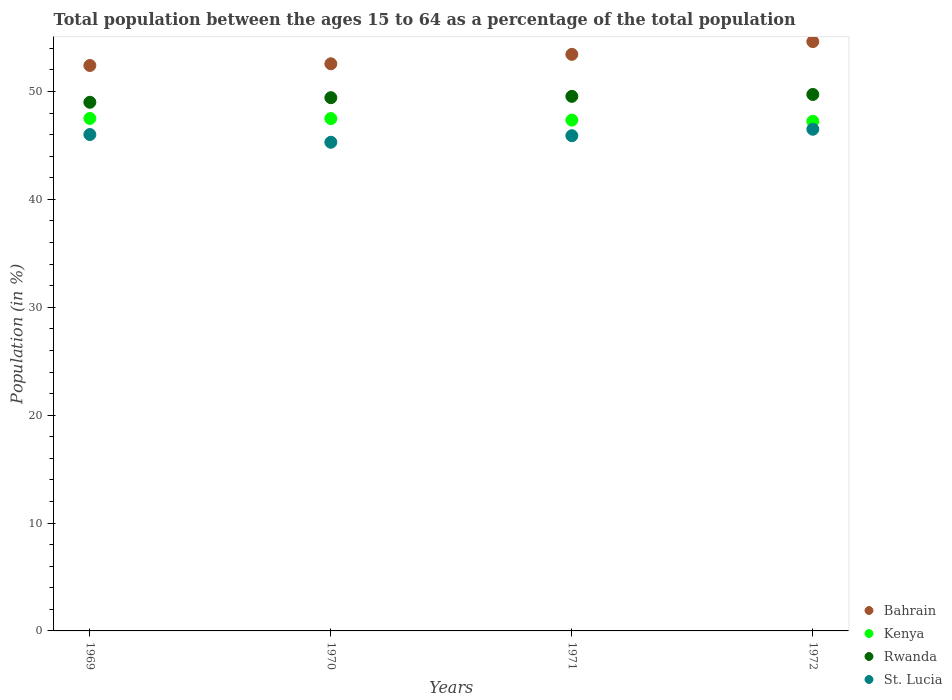What is the percentage of the population ages 15 to 64 in Bahrain in 1969?
Ensure brevity in your answer.  52.42. Across all years, what is the maximum percentage of the population ages 15 to 64 in St. Lucia?
Offer a terse response. 46.5. Across all years, what is the minimum percentage of the population ages 15 to 64 in Kenya?
Offer a very short reply. 47.24. In which year was the percentage of the population ages 15 to 64 in Kenya maximum?
Keep it short and to the point. 1969. In which year was the percentage of the population ages 15 to 64 in St. Lucia minimum?
Make the answer very short. 1970. What is the total percentage of the population ages 15 to 64 in Rwanda in the graph?
Your response must be concise. 197.72. What is the difference between the percentage of the population ages 15 to 64 in St. Lucia in 1969 and that in 1970?
Provide a succinct answer. 0.72. What is the difference between the percentage of the population ages 15 to 64 in St. Lucia in 1971 and the percentage of the population ages 15 to 64 in Bahrain in 1970?
Give a very brief answer. -6.67. What is the average percentage of the population ages 15 to 64 in Kenya per year?
Offer a very short reply. 47.4. In the year 1969, what is the difference between the percentage of the population ages 15 to 64 in Rwanda and percentage of the population ages 15 to 64 in Kenya?
Give a very brief answer. 1.5. What is the ratio of the percentage of the population ages 15 to 64 in St. Lucia in 1969 to that in 1972?
Offer a very short reply. 0.99. Is the difference between the percentage of the population ages 15 to 64 in Rwanda in 1970 and 1972 greater than the difference between the percentage of the population ages 15 to 64 in Kenya in 1970 and 1972?
Make the answer very short. No. What is the difference between the highest and the second highest percentage of the population ages 15 to 64 in Bahrain?
Keep it short and to the point. 1.18. What is the difference between the highest and the lowest percentage of the population ages 15 to 64 in Kenya?
Your answer should be compact. 0.27. Is the sum of the percentage of the population ages 15 to 64 in Rwanda in 1971 and 1972 greater than the maximum percentage of the population ages 15 to 64 in Kenya across all years?
Your answer should be compact. Yes. Is it the case that in every year, the sum of the percentage of the population ages 15 to 64 in Kenya and percentage of the population ages 15 to 64 in Rwanda  is greater than the sum of percentage of the population ages 15 to 64 in St. Lucia and percentage of the population ages 15 to 64 in Bahrain?
Provide a short and direct response. Yes. Is it the case that in every year, the sum of the percentage of the population ages 15 to 64 in Bahrain and percentage of the population ages 15 to 64 in Rwanda  is greater than the percentage of the population ages 15 to 64 in St. Lucia?
Provide a short and direct response. Yes. How many years are there in the graph?
Give a very brief answer. 4. What is the difference between two consecutive major ticks on the Y-axis?
Make the answer very short. 10. Does the graph contain any zero values?
Give a very brief answer. No. How many legend labels are there?
Ensure brevity in your answer.  4. What is the title of the graph?
Offer a terse response. Total population between the ages 15 to 64 as a percentage of the total population. Does "Saudi Arabia" appear as one of the legend labels in the graph?
Offer a very short reply. No. What is the label or title of the X-axis?
Offer a terse response. Years. What is the label or title of the Y-axis?
Your answer should be compact. Population (in %). What is the Population (in %) of Bahrain in 1969?
Provide a succinct answer. 52.42. What is the Population (in %) in Kenya in 1969?
Give a very brief answer. 47.51. What is the Population (in %) in Rwanda in 1969?
Offer a terse response. 49. What is the Population (in %) in St. Lucia in 1969?
Keep it short and to the point. 46.01. What is the Population (in %) of Bahrain in 1970?
Your answer should be very brief. 52.57. What is the Population (in %) in Kenya in 1970?
Offer a very short reply. 47.49. What is the Population (in %) of Rwanda in 1970?
Provide a succinct answer. 49.43. What is the Population (in %) in St. Lucia in 1970?
Your answer should be compact. 45.3. What is the Population (in %) of Bahrain in 1971?
Give a very brief answer. 53.45. What is the Population (in %) in Kenya in 1971?
Provide a short and direct response. 47.35. What is the Population (in %) of Rwanda in 1971?
Provide a short and direct response. 49.55. What is the Population (in %) in St. Lucia in 1971?
Your response must be concise. 45.91. What is the Population (in %) of Bahrain in 1972?
Make the answer very short. 54.63. What is the Population (in %) in Kenya in 1972?
Provide a short and direct response. 47.24. What is the Population (in %) of Rwanda in 1972?
Ensure brevity in your answer.  49.73. What is the Population (in %) of St. Lucia in 1972?
Your answer should be very brief. 46.5. Across all years, what is the maximum Population (in %) of Bahrain?
Your answer should be compact. 54.63. Across all years, what is the maximum Population (in %) of Kenya?
Offer a terse response. 47.51. Across all years, what is the maximum Population (in %) in Rwanda?
Your response must be concise. 49.73. Across all years, what is the maximum Population (in %) of St. Lucia?
Make the answer very short. 46.5. Across all years, what is the minimum Population (in %) in Bahrain?
Your answer should be very brief. 52.42. Across all years, what is the minimum Population (in %) of Kenya?
Offer a very short reply. 47.24. Across all years, what is the minimum Population (in %) of Rwanda?
Offer a very short reply. 49. Across all years, what is the minimum Population (in %) of St. Lucia?
Provide a short and direct response. 45.3. What is the total Population (in %) of Bahrain in the graph?
Make the answer very short. 213.07. What is the total Population (in %) in Kenya in the graph?
Give a very brief answer. 189.59. What is the total Population (in %) of Rwanda in the graph?
Your response must be concise. 197.72. What is the total Population (in %) of St. Lucia in the graph?
Provide a succinct answer. 183.72. What is the difference between the Population (in %) of Bahrain in 1969 and that in 1970?
Provide a succinct answer. -0.16. What is the difference between the Population (in %) in Kenya in 1969 and that in 1970?
Ensure brevity in your answer.  0.01. What is the difference between the Population (in %) of Rwanda in 1969 and that in 1970?
Keep it short and to the point. -0.43. What is the difference between the Population (in %) in St. Lucia in 1969 and that in 1970?
Give a very brief answer. 0.72. What is the difference between the Population (in %) of Bahrain in 1969 and that in 1971?
Provide a short and direct response. -1.03. What is the difference between the Population (in %) in Kenya in 1969 and that in 1971?
Your answer should be very brief. 0.15. What is the difference between the Population (in %) in Rwanda in 1969 and that in 1971?
Make the answer very short. -0.55. What is the difference between the Population (in %) of St. Lucia in 1969 and that in 1971?
Provide a succinct answer. 0.11. What is the difference between the Population (in %) of Bahrain in 1969 and that in 1972?
Ensure brevity in your answer.  -2.21. What is the difference between the Population (in %) of Kenya in 1969 and that in 1972?
Make the answer very short. 0.27. What is the difference between the Population (in %) in Rwanda in 1969 and that in 1972?
Keep it short and to the point. -0.72. What is the difference between the Population (in %) of St. Lucia in 1969 and that in 1972?
Offer a very short reply. -0.49. What is the difference between the Population (in %) of Bahrain in 1970 and that in 1971?
Offer a terse response. -0.87. What is the difference between the Population (in %) in Kenya in 1970 and that in 1971?
Keep it short and to the point. 0.14. What is the difference between the Population (in %) in Rwanda in 1970 and that in 1971?
Your answer should be very brief. -0.12. What is the difference between the Population (in %) of St. Lucia in 1970 and that in 1971?
Ensure brevity in your answer.  -0.61. What is the difference between the Population (in %) of Bahrain in 1970 and that in 1972?
Make the answer very short. -2.05. What is the difference between the Population (in %) of Kenya in 1970 and that in 1972?
Provide a short and direct response. 0.25. What is the difference between the Population (in %) in Rwanda in 1970 and that in 1972?
Offer a terse response. -0.3. What is the difference between the Population (in %) of St. Lucia in 1970 and that in 1972?
Provide a succinct answer. -1.21. What is the difference between the Population (in %) in Bahrain in 1971 and that in 1972?
Provide a succinct answer. -1.18. What is the difference between the Population (in %) in Kenya in 1971 and that in 1972?
Keep it short and to the point. 0.11. What is the difference between the Population (in %) of Rwanda in 1971 and that in 1972?
Your answer should be very brief. -0.18. What is the difference between the Population (in %) of St. Lucia in 1971 and that in 1972?
Your response must be concise. -0.6. What is the difference between the Population (in %) in Bahrain in 1969 and the Population (in %) in Kenya in 1970?
Make the answer very short. 4.92. What is the difference between the Population (in %) in Bahrain in 1969 and the Population (in %) in Rwanda in 1970?
Offer a very short reply. 2.98. What is the difference between the Population (in %) in Bahrain in 1969 and the Population (in %) in St. Lucia in 1970?
Offer a terse response. 7.12. What is the difference between the Population (in %) in Kenya in 1969 and the Population (in %) in Rwanda in 1970?
Your answer should be very brief. -1.93. What is the difference between the Population (in %) of Kenya in 1969 and the Population (in %) of St. Lucia in 1970?
Your answer should be very brief. 2.21. What is the difference between the Population (in %) of Rwanda in 1969 and the Population (in %) of St. Lucia in 1970?
Ensure brevity in your answer.  3.71. What is the difference between the Population (in %) of Bahrain in 1969 and the Population (in %) of Kenya in 1971?
Offer a terse response. 5.06. What is the difference between the Population (in %) of Bahrain in 1969 and the Population (in %) of Rwanda in 1971?
Make the answer very short. 2.86. What is the difference between the Population (in %) in Bahrain in 1969 and the Population (in %) in St. Lucia in 1971?
Keep it short and to the point. 6.51. What is the difference between the Population (in %) in Kenya in 1969 and the Population (in %) in Rwanda in 1971?
Make the answer very short. -2.05. What is the difference between the Population (in %) in Kenya in 1969 and the Population (in %) in St. Lucia in 1971?
Provide a succinct answer. 1.6. What is the difference between the Population (in %) of Rwanda in 1969 and the Population (in %) of St. Lucia in 1971?
Your answer should be very brief. 3.1. What is the difference between the Population (in %) in Bahrain in 1969 and the Population (in %) in Kenya in 1972?
Your answer should be very brief. 5.18. What is the difference between the Population (in %) of Bahrain in 1969 and the Population (in %) of Rwanda in 1972?
Ensure brevity in your answer.  2.69. What is the difference between the Population (in %) of Bahrain in 1969 and the Population (in %) of St. Lucia in 1972?
Your response must be concise. 5.91. What is the difference between the Population (in %) in Kenya in 1969 and the Population (in %) in Rwanda in 1972?
Offer a very short reply. -2.22. What is the difference between the Population (in %) of Kenya in 1969 and the Population (in %) of St. Lucia in 1972?
Offer a very short reply. 1. What is the difference between the Population (in %) in Rwanda in 1969 and the Population (in %) in St. Lucia in 1972?
Give a very brief answer. 2.5. What is the difference between the Population (in %) in Bahrain in 1970 and the Population (in %) in Kenya in 1971?
Make the answer very short. 5.22. What is the difference between the Population (in %) in Bahrain in 1970 and the Population (in %) in Rwanda in 1971?
Ensure brevity in your answer.  3.02. What is the difference between the Population (in %) of Bahrain in 1970 and the Population (in %) of St. Lucia in 1971?
Ensure brevity in your answer.  6.67. What is the difference between the Population (in %) of Kenya in 1970 and the Population (in %) of Rwanda in 1971?
Offer a terse response. -2.06. What is the difference between the Population (in %) of Kenya in 1970 and the Population (in %) of St. Lucia in 1971?
Your answer should be compact. 1.59. What is the difference between the Population (in %) of Rwanda in 1970 and the Population (in %) of St. Lucia in 1971?
Keep it short and to the point. 3.53. What is the difference between the Population (in %) of Bahrain in 1970 and the Population (in %) of Kenya in 1972?
Your response must be concise. 5.33. What is the difference between the Population (in %) in Bahrain in 1970 and the Population (in %) in Rwanda in 1972?
Make the answer very short. 2.85. What is the difference between the Population (in %) in Bahrain in 1970 and the Population (in %) in St. Lucia in 1972?
Make the answer very short. 6.07. What is the difference between the Population (in %) of Kenya in 1970 and the Population (in %) of Rwanda in 1972?
Provide a short and direct response. -2.24. What is the difference between the Population (in %) in Kenya in 1970 and the Population (in %) in St. Lucia in 1972?
Provide a succinct answer. 0.99. What is the difference between the Population (in %) of Rwanda in 1970 and the Population (in %) of St. Lucia in 1972?
Give a very brief answer. 2.93. What is the difference between the Population (in %) of Bahrain in 1971 and the Population (in %) of Kenya in 1972?
Your response must be concise. 6.21. What is the difference between the Population (in %) of Bahrain in 1971 and the Population (in %) of Rwanda in 1972?
Provide a succinct answer. 3.72. What is the difference between the Population (in %) of Bahrain in 1971 and the Population (in %) of St. Lucia in 1972?
Your answer should be very brief. 6.94. What is the difference between the Population (in %) in Kenya in 1971 and the Population (in %) in Rwanda in 1972?
Your response must be concise. -2.38. What is the difference between the Population (in %) in Kenya in 1971 and the Population (in %) in St. Lucia in 1972?
Make the answer very short. 0.85. What is the difference between the Population (in %) in Rwanda in 1971 and the Population (in %) in St. Lucia in 1972?
Your response must be concise. 3.05. What is the average Population (in %) of Bahrain per year?
Make the answer very short. 53.27. What is the average Population (in %) of Kenya per year?
Make the answer very short. 47.4. What is the average Population (in %) of Rwanda per year?
Your answer should be very brief. 49.43. What is the average Population (in %) of St. Lucia per year?
Your response must be concise. 45.93. In the year 1969, what is the difference between the Population (in %) of Bahrain and Population (in %) of Kenya?
Offer a terse response. 4.91. In the year 1969, what is the difference between the Population (in %) of Bahrain and Population (in %) of Rwanda?
Offer a terse response. 3.41. In the year 1969, what is the difference between the Population (in %) in Bahrain and Population (in %) in St. Lucia?
Give a very brief answer. 6.4. In the year 1969, what is the difference between the Population (in %) in Kenya and Population (in %) in Rwanda?
Give a very brief answer. -1.5. In the year 1969, what is the difference between the Population (in %) of Kenya and Population (in %) of St. Lucia?
Your response must be concise. 1.49. In the year 1969, what is the difference between the Population (in %) of Rwanda and Population (in %) of St. Lucia?
Provide a short and direct response. 2.99. In the year 1970, what is the difference between the Population (in %) of Bahrain and Population (in %) of Kenya?
Your response must be concise. 5.08. In the year 1970, what is the difference between the Population (in %) in Bahrain and Population (in %) in Rwanda?
Provide a short and direct response. 3.14. In the year 1970, what is the difference between the Population (in %) of Bahrain and Population (in %) of St. Lucia?
Ensure brevity in your answer.  7.28. In the year 1970, what is the difference between the Population (in %) of Kenya and Population (in %) of Rwanda?
Provide a short and direct response. -1.94. In the year 1970, what is the difference between the Population (in %) of Kenya and Population (in %) of St. Lucia?
Your response must be concise. 2.19. In the year 1970, what is the difference between the Population (in %) of Rwanda and Population (in %) of St. Lucia?
Offer a very short reply. 4.13. In the year 1971, what is the difference between the Population (in %) of Bahrain and Population (in %) of Kenya?
Offer a very short reply. 6.1. In the year 1971, what is the difference between the Population (in %) of Bahrain and Population (in %) of Rwanda?
Give a very brief answer. 3.9. In the year 1971, what is the difference between the Population (in %) of Bahrain and Population (in %) of St. Lucia?
Provide a short and direct response. 7.54. In the year 1971, what is the difference between the Population (in %) of Kenya and Population (in %) of Rwanda?
Provide a succinct answer. -2.2. In the year 1971, what is the difference between the Population (in %) of Kenya and Population (in %) of St. Lucia?
Your answer should be very brief. 1.45. In the year 1971, what is the difference between the Population (in %) of Rwanda and Population (in %) of St. Lucia?
Provide a short and direct response. 3.65. In the year 1972, what is the difference between the Population (in %) in Bahrain and Population (in %) in Kenya?
Give a very brief answer. 7.39. In the year 1972, what is the difference between the Population (in %) of Bahrain and Population (in %) of Rwanda?
Give a very brief answer. 4.9. In the year 1972, what is the difference between the Population (in %) in Bahrain and Population (in %) in St. Lucia?
Your answer should be very brief. 8.12. In the year 1972, what is the difference between the Population (in %) of Kenya and Population (in %) of Rwanda?
Offer a terse response. -2.49. In the year 1972, what is the difference between the Population (in %) of Kenya and Population (in %) of St. Lucia?
Give a very brief answer. 0.73. In the year 1972, what is the difference between the Population (in %) in Rwanda and Population (in %) in St. Lucia?
Keep it short and to the point. 3.22. What is the ratio of the Population (in %) in Bahrain in 1969 to that in 1970?
Ensure brevity in your answer.  1. What is the ratio of the Population (in %) of Kenya in 1969 to that in 1970?
Provide a short and direct response. 1. What is the ratio of the Population (in %) in Rwanda in 1969 to that in 1970?
Offer a terse response. 0.99. What is the ratio of the Population (in %) of St. Lucia in 1969 to that in 1970?
Offer a very short reply. 1.02. What is the ratio of the Population (in %) of Bahrain in 1969 to that in 1971?
Make the answer very short. 0.98. What is the ratio of the Population (in %) in Kenya in 1969 to that in 1971?
Your answer should be very brief. 1. What is the ratio of the Population (in %) in St. Lucia in 1969 to that in 1971?
Ensure brevity in your answer.  1. What is the ratio of the Population (in %) of Bahrain in 1969 to that in 1972?
Keep it short and to the point. 0.96. What is the ratio of the Population (in %) of Kenya in 1969 to that in 1972?
Ensure brevity in your answer.  1.01. What is the ratio of the Population (in %) of Rwanda in 1969 to that in 1972?
Your answer should be compact. 0.99. What is the ratio of the Population (in %) of St. Lucia in 1969 to that in 1972?
Provide a succinct answer. 0.99. What is the ratio of the Population (in %) of Bahrain in 1970 to that in 1971?
Your answer should be very brief. 0.98. What is the ratio of the Population (in %) of Kenya in 1970 to that in 1971?
Your response must be concise. 1. What is the ratio of the Population (in %) in St. Lucia in 1970 to that in 1971?
Give a very brief answer. 0.99. What is the ratio of the Population (in %) of Bahrain in 1970 to that in 1972?
Provide a succinct answer. 0.96. What is the ratio of the Population (in %) of Kenya in 1970 to that in 1972?
Offer a terse response. 1.01. What is the ratio of the Population (in %) in Rwanda in 1970 to that in 1972?
Offer a very short reply. 0.99. What is the ratio of the Population (in %) in St. Lucia in 1970 to that in 1972?
Your answer should be very brief. 0.97. What is the ratio of the Population (in %) in Bahrain in 1971 to that in 1972?
Ensure brevity in your answer.  0.98. What is the ratio of the Population (in %) in St. Lucia in 1971 to that in 1972?
Your response must be concise. 0.99. What is the difference between the highest and the second highest Population (in %) of Bahrain?
Provide a short and direct response. 1.18. What is the difference between the highest and the second highest Population (in %) of Kenya?
Your response must be concise. 0.01. What is the difference between the highest and the second highest Population (in %) of Rwanda?
Offer a very short reply. 0.18. What is the difference between the highest and the second highest Population (in %) of St. Lucia?
Offer a very short reply. 0.49. What is the difference between the highest and the lowest Population (in %) in Bahrain?
Offer a very short reply. 2.21. What is the difference between the highest and the lowest Population (in %) of Kenya?
Your response must be concise. 0.27. What is the difference between the highest and the lowest Population (in %) in Rwanda?
Ensure brevity in your answer.  0.72. What is the difference between the highest and the lowest Population (in %) of St. Lucia?
Keep it short and to the point. 1.21. 